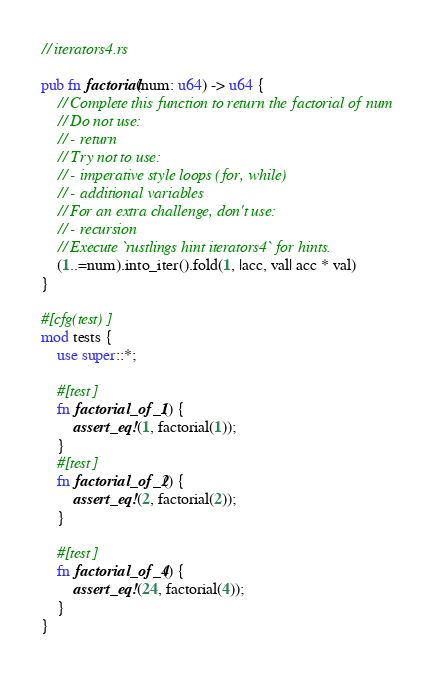<code> <loc_0><loc_0><loc_500><loc_500><_Rust_>// iterators4.rs

pub fn factorial(num: u64) -> u64 {
    // Complete this function to return the factorial of num
    // Do not use:
    // - return
    // Try not to use:
    // - imperative style loops (for, while)
    // - additional variables
    // For an extra challenge, don't use:
    // - recursion
    // Execute `rustlings hint iterators4` for hints.
    (1..=num).into_iter().fold(1, |acc, val| acc * val)
}

#[cfg(test)]
mod tests {
    use super::*;

    #[test]
    fn factorial_of_1() {
        assert_eq!(1, factorial(1));
    }
    #[test]
    fn factorial_of_2() {
        assert_eq!(2, factorial(2));
    }

    #[test]
    fn factorial_of_4() {
        assert_eq!(24, factorial(4));
    }
}
</code> 